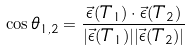<formula> <loc_0><loc_0><loc_500><loc_500>\cos \theta _ { 1 , 2 } = \frac { \vec { \epsilon } ( T _ { 1 } ) \cdot \vec { \epsilon } ( T _ { 2 } ) } { | \vec { \epsilon } ( T _ { 1 } ) | | \vec { \epsilon } ( T _ { 2 } ) | }</formula> 